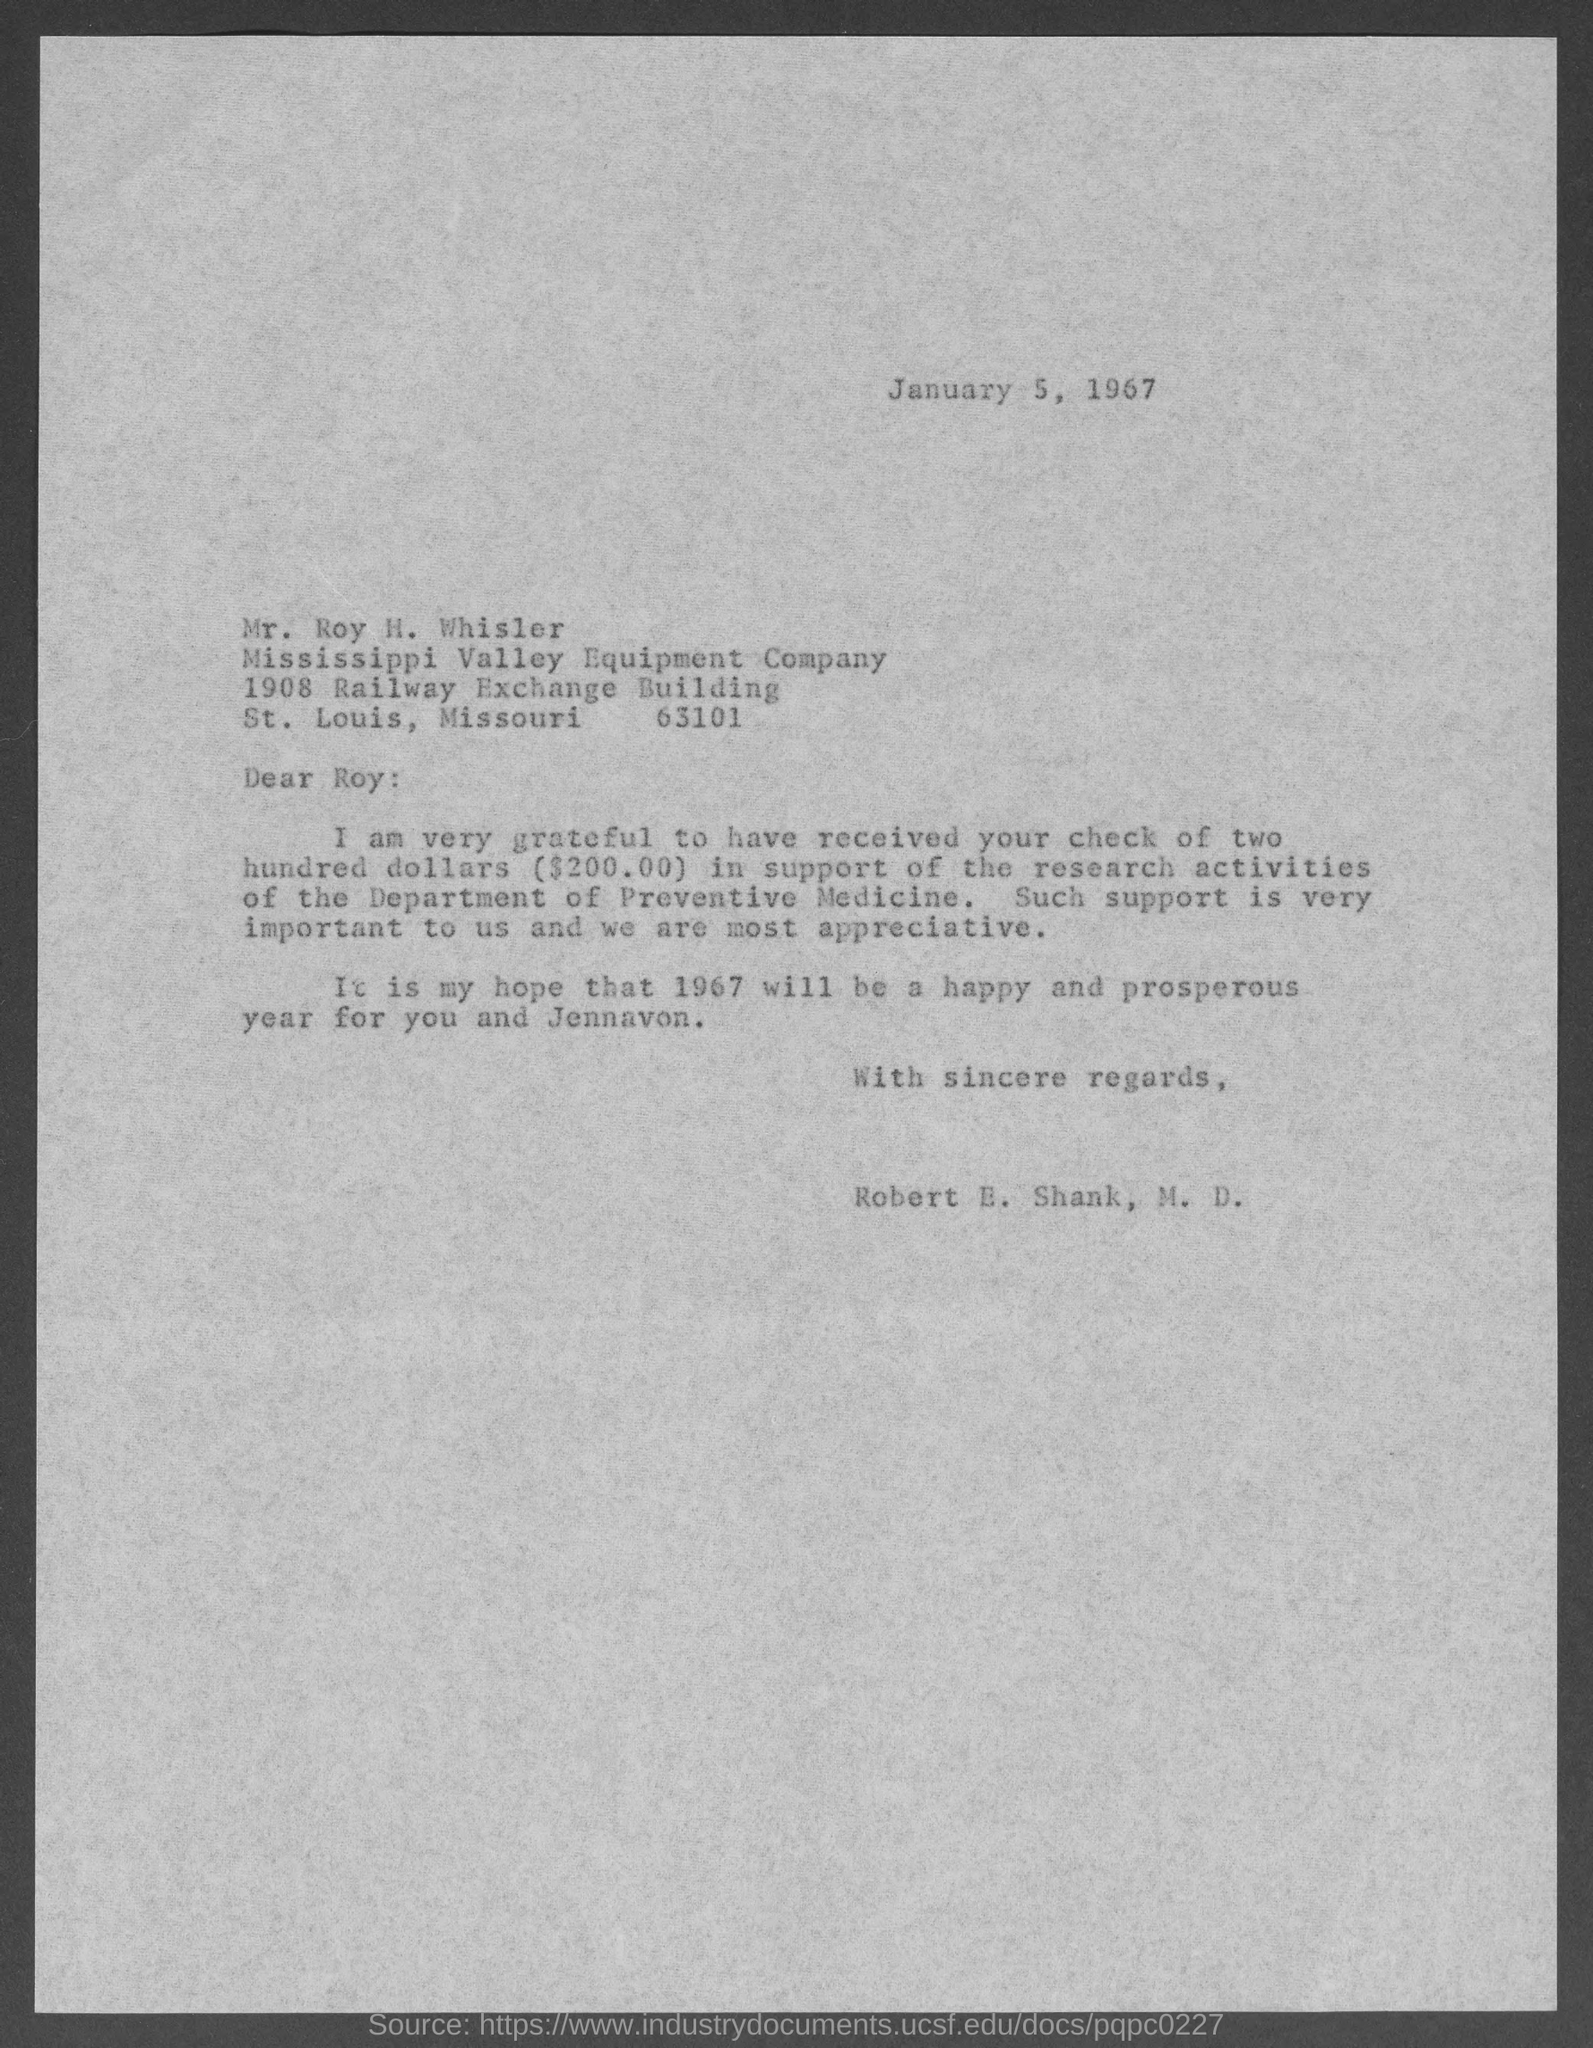What date is this letter written on?
Offer a very short reply. January 5, 1967. To whom this letter is written to?
Provide a succinct answer. Mr. Roy H. Whisler. Who wrote this letter?
Your answer should be very brief. Robert E. Shank, M.D. What amount is the cheque for ?
Your response must be concise. $200.00. To which company does Mr. Roy H. Whisler belong to?
Provide a succinct answer. Mississippi Valley Equipment Company. 